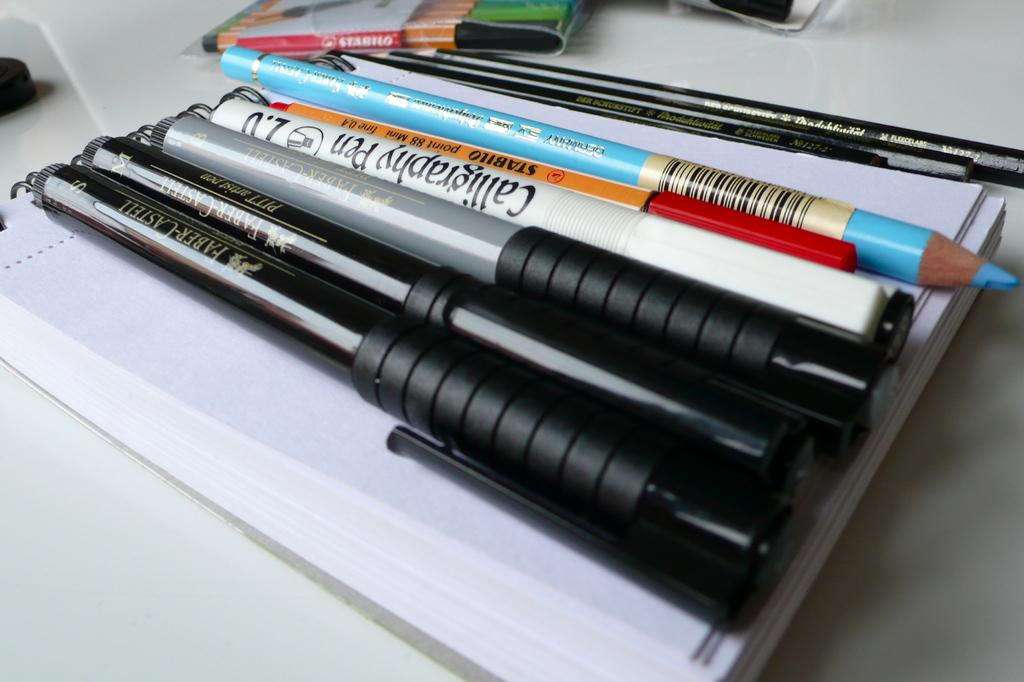What is the main object in the image? There is a book in the image. What is placed on top of the book? Pens and pencils are on the book. Are there any other objects visible in the image? Yes, there are other objects beside the book. How does the string interact with the book in the image? There is no string present in the image, so it cannot interact with the book. 